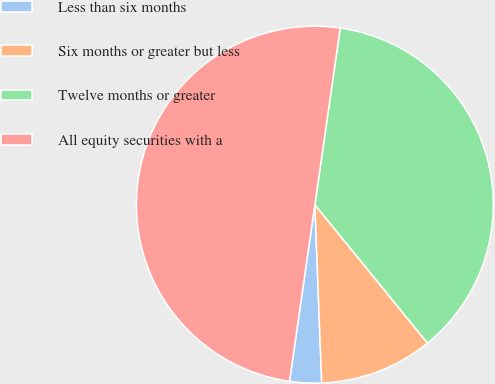<chart> <loc_0><loc_0><loc_500><loc_500><pie_chart><fcel>Less than six months<fcel>Six months or greater but less<fcel>Twelve months or greater<fcel>All equity securities with a<nl><fcel>2.88%<fcel>10.26%<fcel>36.86%<fcel>50.0%<nl></chart> 